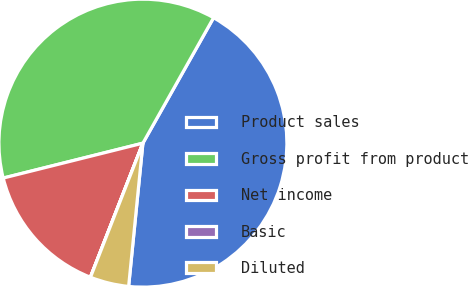<chart> <loc_0><loc_0><loc_500><loc_500><pie_chart><fcel>Product sales<fcel>Gross profit from product<fcel>Net income<fcel>Basic<fcel>Diluted<nl><fcel>43.41%<fcel>37.06%<fcel>15.16%<fcel>0.01%<fcel>4.35%<nl></chart> 